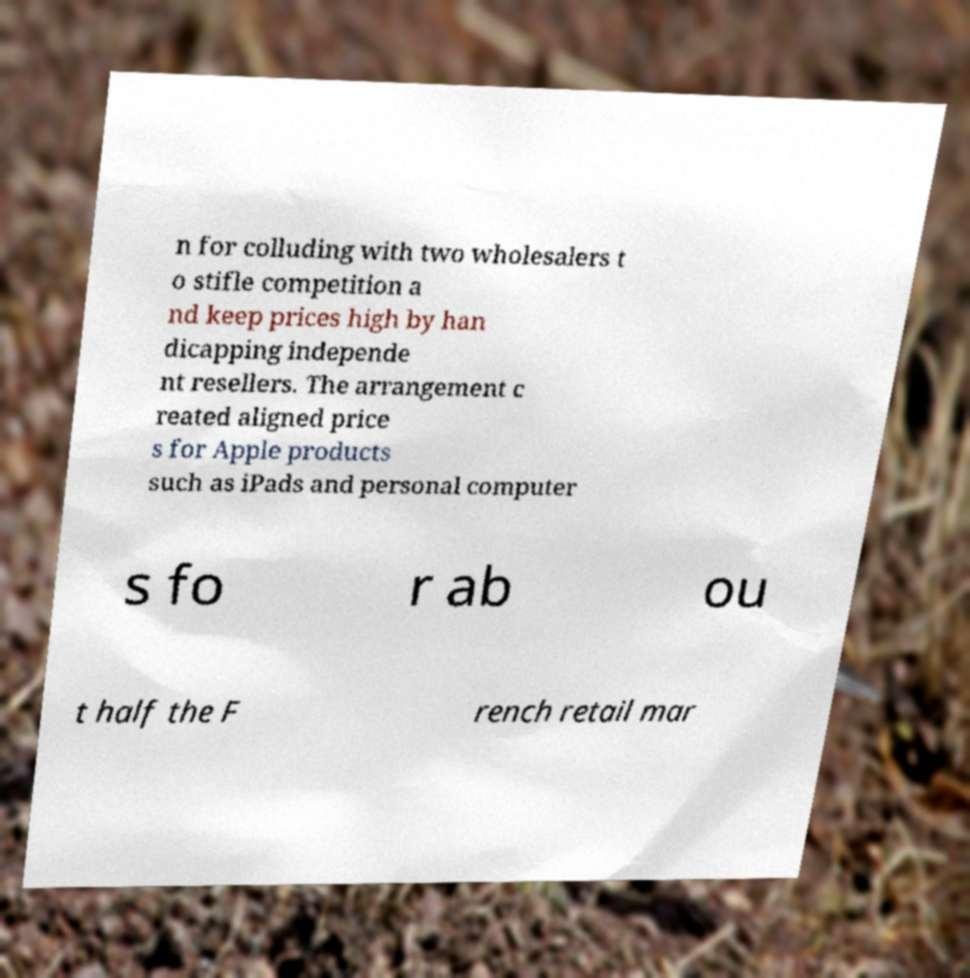For documentation purposes, I need the text within this image transcribed. Could you provide that? n for colluding with two wholesalers t o stifle competition a nd keep prices high by han dicapping independe nt resellers. The arrangement c reated aligned price s for Apple products such as iPads and personal computer s fo r ab ou t half the F rench retail mar 